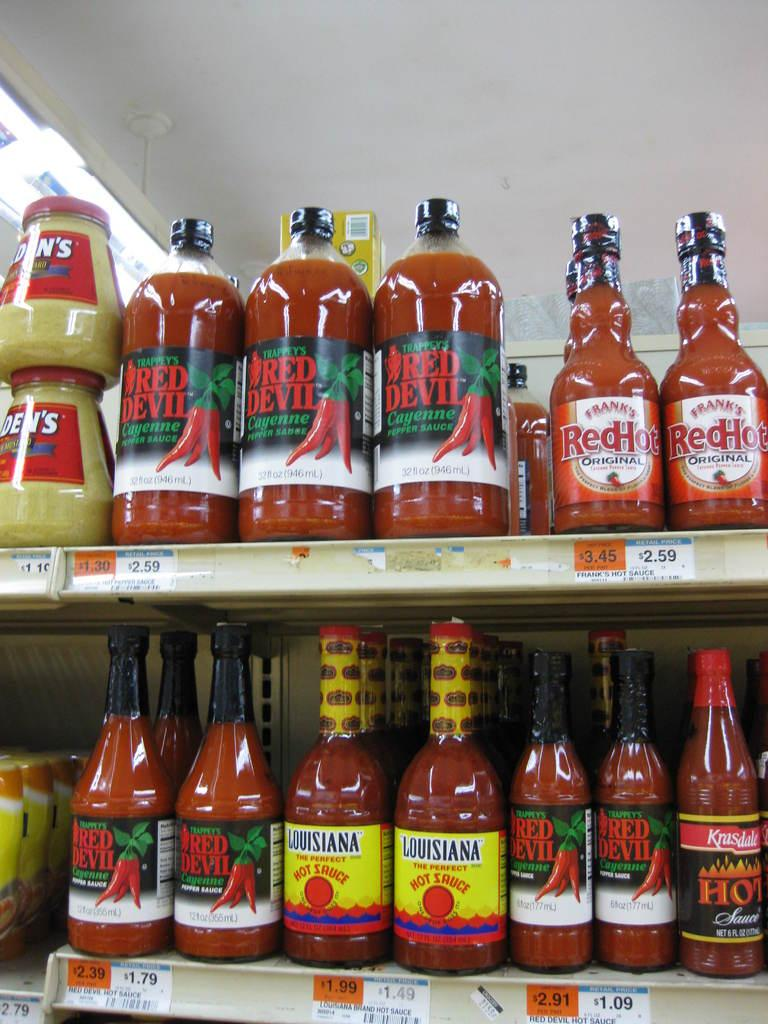Provide a one-sentence caption for the provided image. Store selling many hot sauces including Frank's Red Hot. 